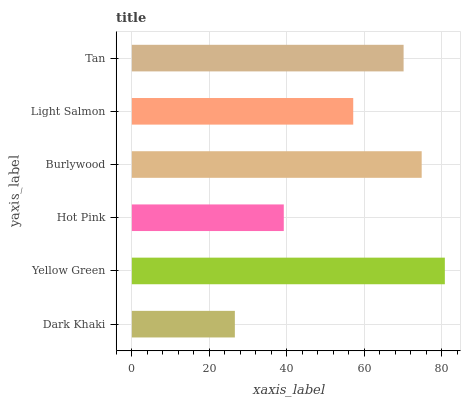Is Dark Khaki the minimum?
Answer yes or no. Yes. Is Yellow Green the maximum?
Answer yes or no. Yes. Is Hot Pink the minimum?
Answer yes or no. No. Is Hot Pink the maximum?
Answer yes or no. No. Is Yellow Green greater than Hot Pink?
Answer yes or no. Yes. Is Hot Pink less than Yellow Green?
Answer yes or no. Yes. Is Hot Pink greater than Yellow Green?
Answer yes or no. No. Is Yellow Green less than Hot Pink?
Answer yes or no. No. Is Tan the high median?
Answer yes or no. Yes. Is Light Salmon the low median?
Answer yes or no. Yes. Is Yellow Green the high median?
Answer yes or no. No. Is Hot Pink the low median?
Answer yes or no. No. 